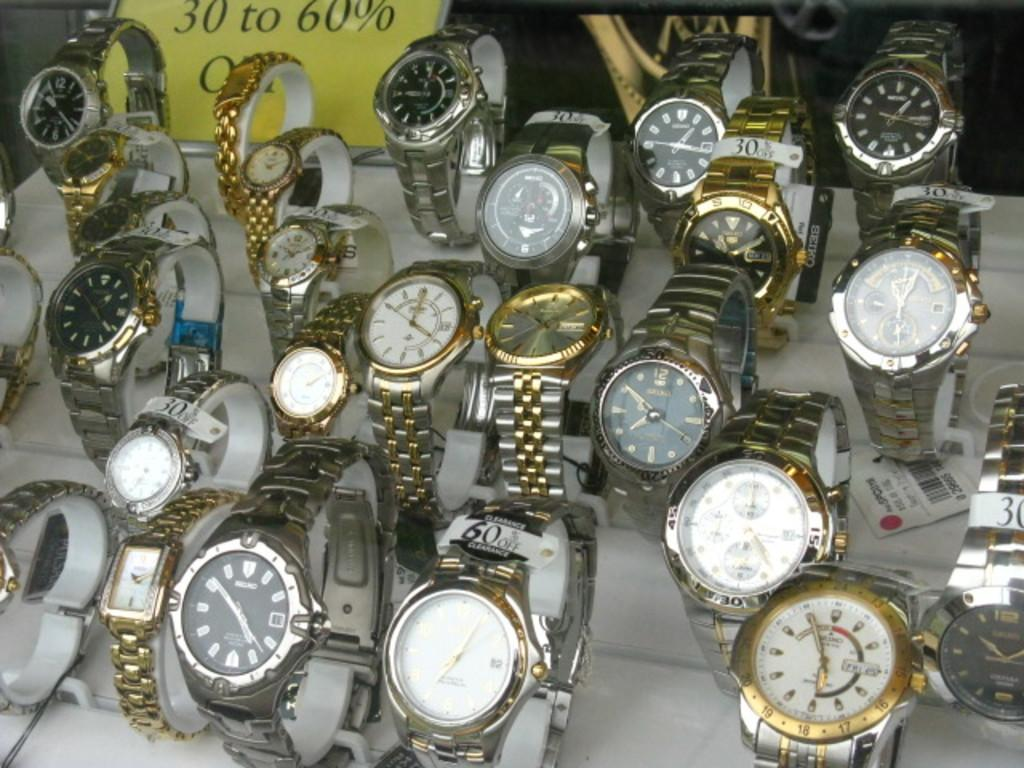What is located at the bottom of the image? There is a table at the bottom of the image. What items can be seen on the table? There are watches and a banner on the table. How many apples are on the table in the image? There is no mention of apples in the image, so we cannot determine the number of apples present. Can you describe the jellyfish swimming on the table in the image? There is no mention of a jellyfish in the image; it only features a table, watches, and a banner. 